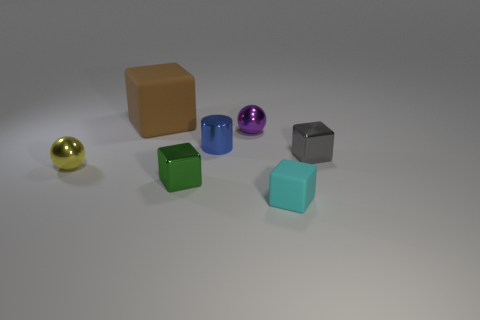Subtract 1 blocks. How many blocks are left? 3 Subtract all purple cubes. Subtract all purple spheres. How many cubes are left? 4 Add 2 tiny green shiny blocks. How many objects exist? 9 Subtract all blocks. How many objects are left? 3 Add 4 tiny cyan rubber blocks. How many tiny cyan rubber blocks exist? 5 Subtract 0 gray cylinders. How many objects are left? 7 Subtract all blue things. Subtract all small cyan matte objects. How many objects are left? 5 Add 3 large brown cubes. How many large brown cubes are left? 4 